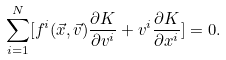Convert formula to latex. <formula><loc_0><loc_0><loc_500><loc_500>\sum _ { i = 1 } ^ { N } [ f ^ { i } ( \vec { x } , \vec { v } ) \frac { \partial K } { \partial v ^ { i } } + v ^ { i } \frac { \partial K } { \partial x ^ { i } } ] = 0 .</formula> 